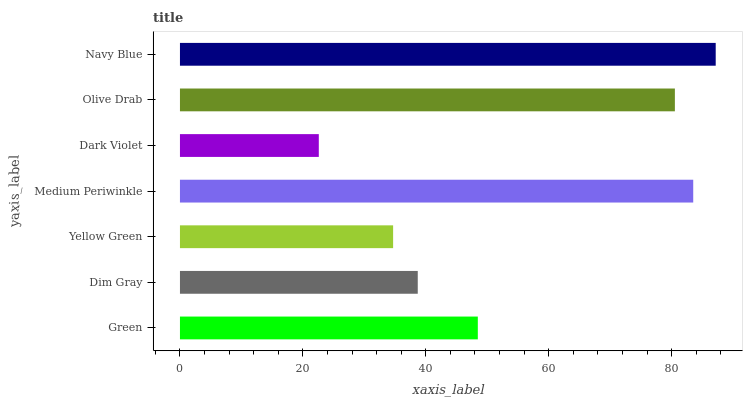Is Dark Violet the minimum?
Answer yes or no. Yes. Is Navy Blue the maximum?
Answer yes or no. Yes. Is Dim Gray the minimum?
Answer yes or no. No. Is Dim Gray the maximum?
Answer yes or no. No. Is Green greater than Dim Gray?
Answer yes or no. Yes. Is Dim Gray less than Green?
Answer yes or no. Yes. Is Dim Gray greater than Green?
Answer yes or no. No. Is Green less than Dim Gray?
Answer yes or no. No. Is Green the high median?
Answer yes or no. Yes. Is Green the low median?
Answer yes or no. Yes. Is Medium Periwinkle the high median?
Answer yes or no. No. Is Navy Blue the low median?
Answer yes or no. No. 